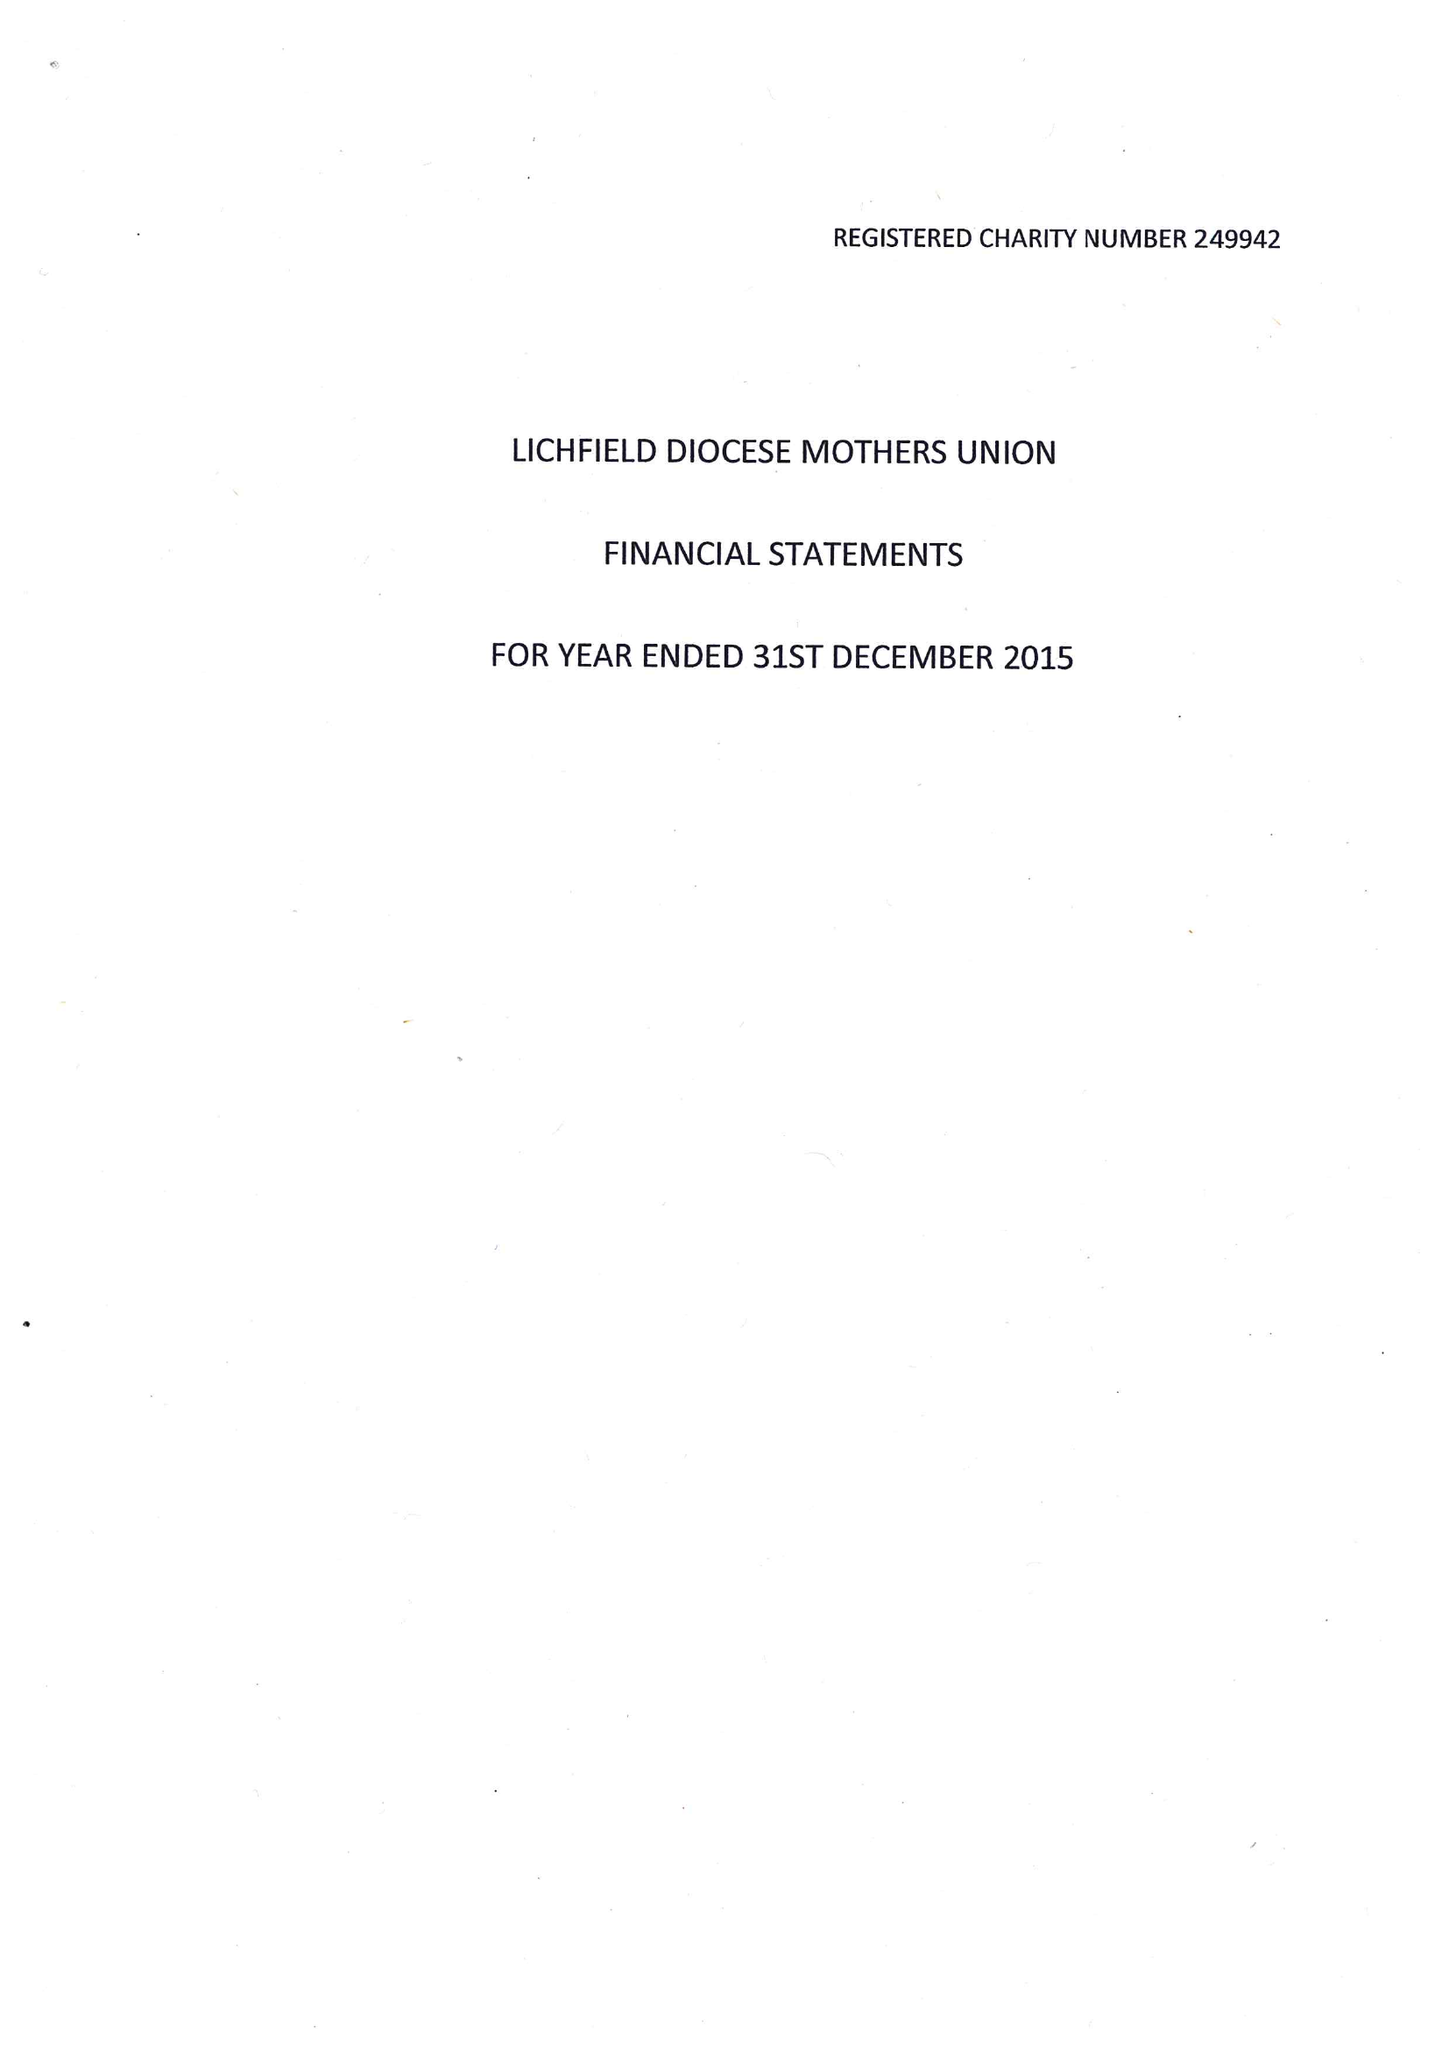What is the value for the address__street_line?
Answer the question using a single word or phrase. 9 POOLFIELD ROAD 